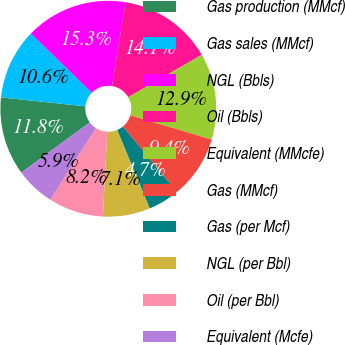<chart> <loc_0><loc_0><loc_500><loc_500><pie_chart><fcel>Gas production (MMcf)<fcel>Gas sales (MMcf)<fcel>NGL (Bbls)<fcel>Oil (Bbls)<fcel>Equivalent (MMcfe)<fcel>Gas (MMcf)<fcel>Gas (per Mcf)<fcel>NGL (per Bbl)<fcel>Oil (per Bbl)<fcel>Equivalent (Mcfe)<nl><fcel>11.76%<fcel>10.59%<fcel>15.29%<fcel>14.12%<fcel>12.94%<fcel>9.41%<fcel>4.71%<fcel>7.06%<fcel>8.24%<fcel>5.88%<nl></chart> 